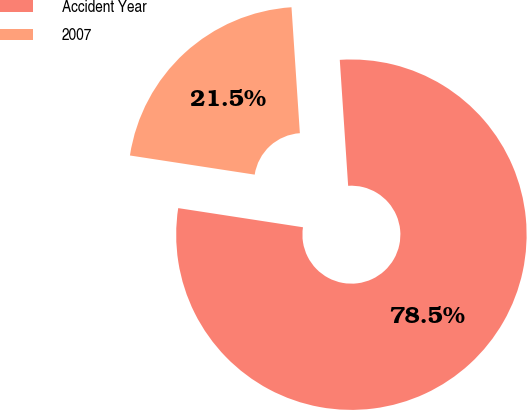Convert chart to OTSL. <chart><loc_0><loc_0><loc_500><loc_500><pie_chart><fcel>Accident Year<fcel>2007<nl><fcel>78.48%<fcel>21.52%<nl></chart> 